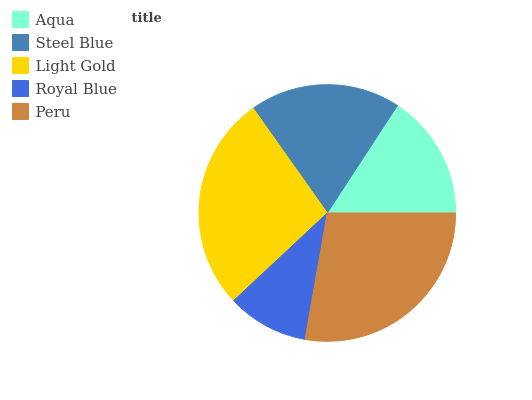Is Royal Blue the minimum?
Answer yes or no. Yes. Is Peru the maximum?
Answer yes or no. Yes. Is Steel Blue the minimum?
Answer yes or no. No. Is Steel Blue the maximum?
Answer yes or no. No. Is Steel Blue greater than Aqua?
Answer yes or no. Yes. Is Aqua less than Steel Blue?
Answer yes or no. Yes. Is Aqua greater than Steel Blue?
Answer yes or no. No. Is Steel Blue less than Aqua?
Answer yes or no. No. Is Steel Blue the high median?
Answer yes or no. Yes. Is Steel Blue the low median?
Answer yes or no. Yes. Is Aqua the high median?
Answer yes or no. No. Is Light Gold the low median?
Answer yes or no. No. 